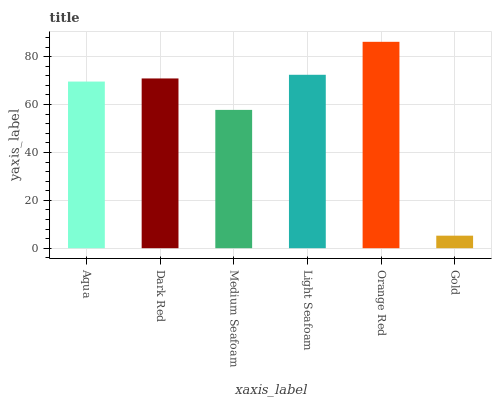Is Dark Red the minimum?
Answer yes or no. No. Is Dark Red the maximum?
Answer yes or no. No. Is Dark Red greater than Aqua?
Answer yes or no. Yes. Is Aqua less than Dark Red?
Answer yes or no. Yes. Is Aqua greater than Dark Red?
Answer yes or no. No. Is Dark Red less than Aqua?
Answer yes or no. No. Is Dark Red the high median?
Answer yes or no. Yes. Is Aqua the low median?
Answer yes or no. Yes. Is Orange Red the high median?
Answer yes or no. No. Is Orange Red the low median?
Answer yes or no. No. 